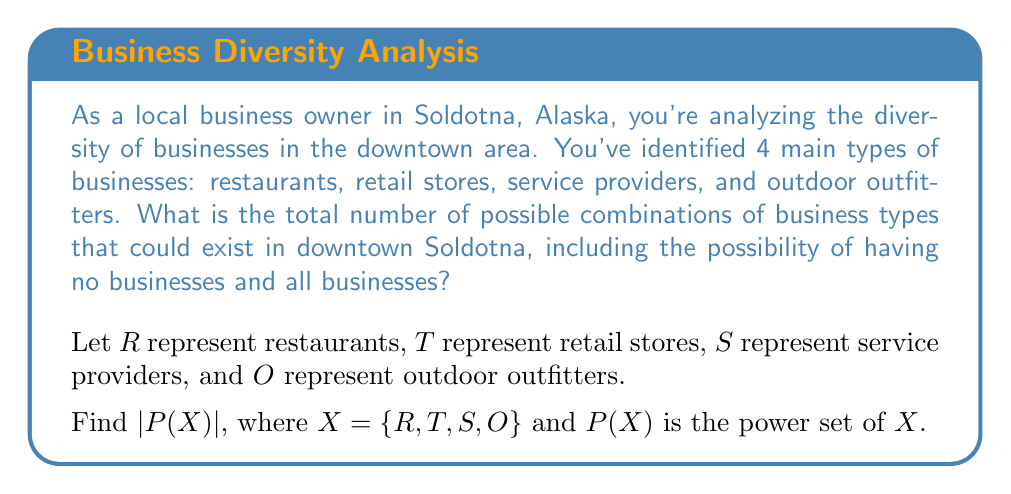Could you help me with this problem? To solve this problem, we need to understand the concept of a power set and how to calculate its cardinality.

1) The power set of a set $X$ is the set of all subsets of $X$, including the empty set $\emptyset$ and $X$ itself.

2) For a set with $n$ elements, the number of elements in its power set is given by $2^n$.

3) In our case, $X = \{R, T, S, O\}$, which has 4 elements.

4) Therefore, $|P(X)| = 2^4 = 16$.

To visualize this, we can list all possible subsets:

$$\begin{align*}
&\{\emptyset\} \\
&\{R\}, \{T\}, \{S\}, \{O\} \\
&\{R,T\}, \{R,S\}, \{R,O\}, \{T,S\}, \{T,O\}, \{S,O\} \\
&\{R,T,S\}, \{R,T,O\}, \{R,S,O\}, \{T,S,O\} \\
&\{R,T,S,O\}
\end{align*}$$

This shows all 16 possible combinations of business types in downtown Soldotna, from having no businesses (represented by the empty set) to having all four types of businesses.
Answer: 16 